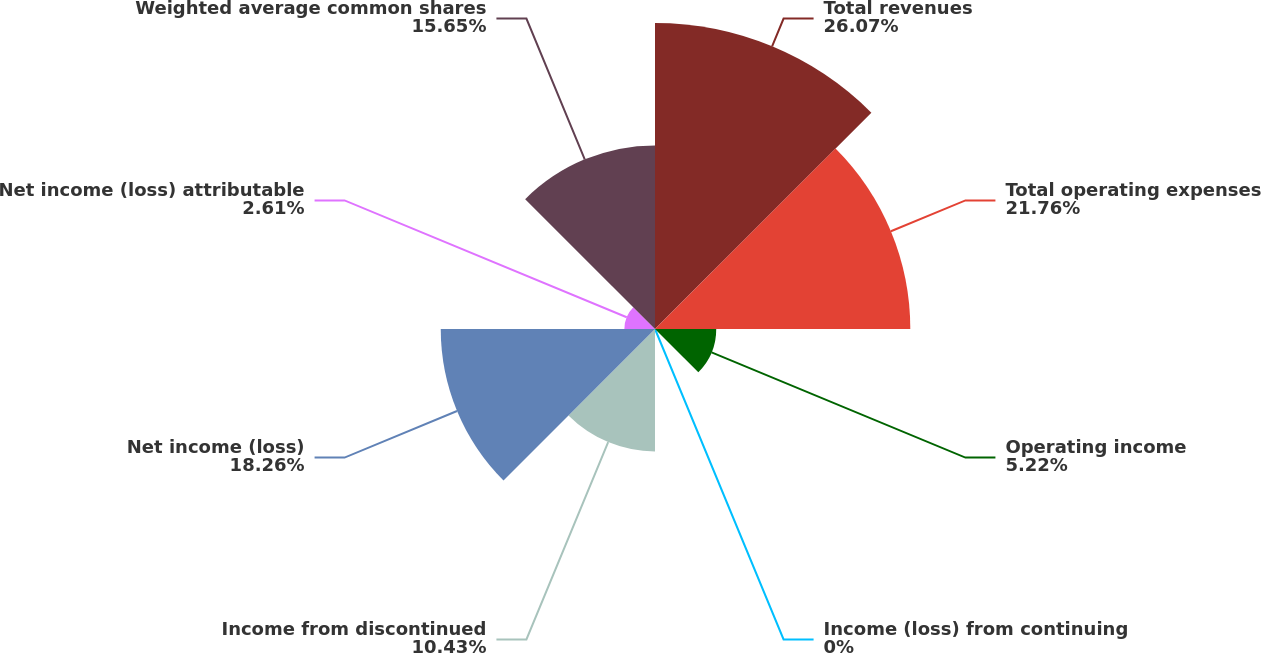Convert chart to OTSL. <chart><loc_0><loc_0><loc_500><loc_500><pie_chart><fcel>Total revenues<fcel>Total operating expenses<fcel>Operating income<fcel>Income (loss) from continuing<fcel>Income from discontinued<fcel>Net income (loss)<fcel>Net income (loss) attributable<fcel>Weighted average common shares<nl><fcel>26.08%<fcel>21.76%<fcel>5.22%<fcel>0.0%<fcel>10.43%<fcel>18.26%<fcel>2.61%<fcel>15.65%<nl></chart> 